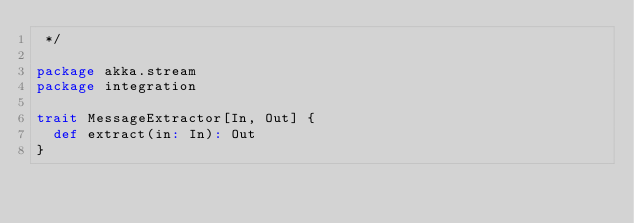Convert code to text. <code><loc_0><loc_0><loc_500><loc_500><_Scala_> */

package akka.stream
package integration

trait MessageExtractor[In, Out] {
  def extract(in: In): Out
}</code> 